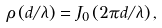Convert formula to latex. <formula><loc_0><loc_0><loc_500><loc_500>\rho \left ( d / \lambda \right ) = J _ { 0 } \left ( 2 \pi d / \lambda \right ) ,</formula> 